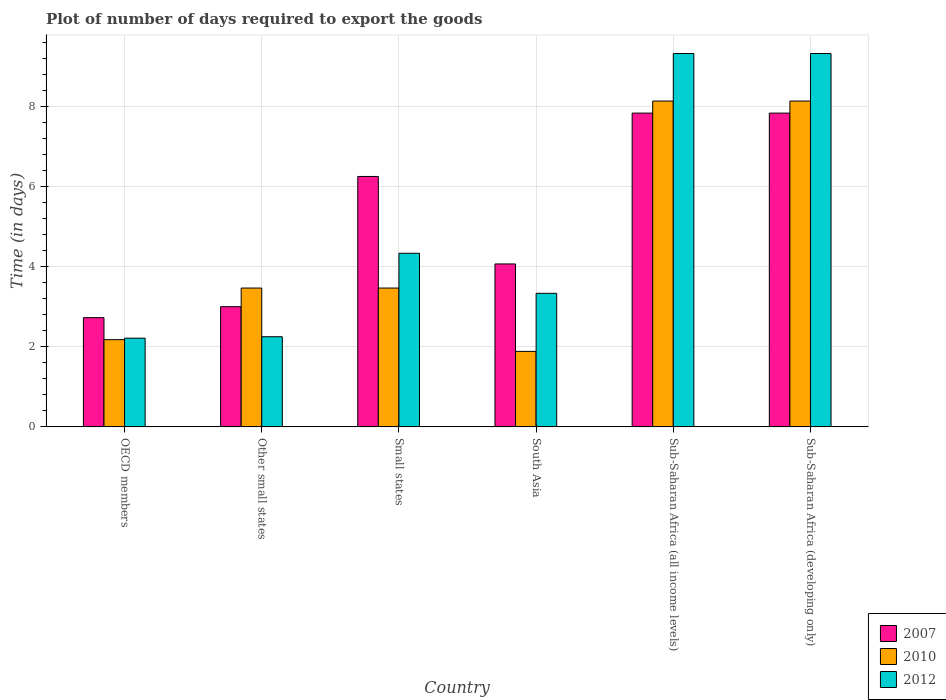How many different coloured bars are there?
Keep it short and to the point. 3. Are the number of bars on each tick of the X-axis equal?
Make the answer very short. Yes. How many bars are there on the 6th tick from the left?
Your response must be concise. 3. How many bars are there on the 2nd tick from the right?
Provide a short and direct response. 3. What is the label of the 2nd group of bars from the left?
Keep it short and to the point. Other small states. Across all countries, what is the maximum time required to export goods in 2010?
Offer a terse response. 8.13. Across all countries, what is the minimum time required to export goods in 2012?
Offer a very short reply. 2.21. In which country was the time required to export goods in 2012 maximum?
Offer a very short reply. Sub-Saharan Africa (all income levels). In which country was the time required to export goods in 2010 minimum?
Your response must be concise. South Asia. What is the total time required to export goods in 2007 in the graph?
Make the answer very short. 31.71. What is the difference between the time required to export goods in 2012 in OECD members and that in Small states?
Give a very brief answer. -2.12. What is the difference between the time required to export goods in 2010 in Small states and the time required to export goods in 2012 in OECD members?
Give a very brief answer. 1.25. What is the average time required to export goods in 2012 per country?
Give a very brief answer. 5.13. What is the difference between the time required to export goods of/in 2007 and time required to export goods of/in 2010 in Small states?
Offer a very short reply. 2.79. In how many countries, is the time required to export goods in 2010 greater than 8 days?
Give a very brief answer. 2. What is the ratio of the time required to export goods in 2010 in Small states to that in South Asia?
Ensure brevity in your answer.  1.84. Is the time required to export goods in 2010 in South Asia less than that in Sub-Saharan Africa (developing only)?
Make the answer very short. Yes. What is the difference between the highest and the second highest time required to export goods in 2010?
Offer a very short reply. 4.67. What is the difference between the highest and the lowest time required to export goods in 2010?
Keep it short and to the point. 6.25. What does the 1st bar from the left in OECD members represents?
Provide a succinct answer. 2007. Is it the case that in every country, the sum of the time required to export goods in 2010 and time required to export goods in 2007 is greater than the time required to export goods in 2012?
Make the answer very short. Yes. How many bars are there?
Keep it short and to the point. 18. Does the graph contain any zero values?
Ensure brevity in your answer.  No. Where does the legend appear in the graph?
Make the answer very short. Bottom right. How are the legend labels stacked?
Offer a very short reply. Vertical. What is the title of the graph?
Offer a very short reply. Plot of number of days required to export the goods. What is the label or title of the Y-axis?
Provide a short and direct response. Time (in days). What is the Time (in days) in 2007 in OECD members?
Provide a short and direct response. 2.73. What is the Time (in days) of 2010 in OECD members?
Provide a succinct answer. 2.18. What is the Time (in days) of 2012 in OECD members?
Your answer should be compact. 2.21. What is the Time (in days) of 2007 in Other small states?
Give a very brief answer. 3. What is the Time (in days) of 2010 in Other small states?
Keep it short and to the point. 3.46. What is the Time (in days) of 2012 in Other small states?
Your answer should be compact. 2.25. What is the Time (in days) of 2007 in Small states?
Keep it short and to the point. 6.25. What is the Time (in days) of 2010 in Small states?
Keep it short and to the point. 3.46. What is the Time (in days) of 2012 in Small states?
Provide a succinct answer. 4.33. What is the Time (in days) of 2007 in South Asia?
Make the answer very short. 4.07. What is the Time (in days) in 2010 in South Asia?
Your answer should be compact. 1.88. What is the Time (in days) of 2012 in South Asia?
Make the answer very short. 3.33. What is the Time (in days) of 2007 in Sub-Saharan Africa (all income levels)?
Offer a very short reply. 7.83. What is the Time (in days) in 2010 in Sub-Saharan Africa (all income levels)?
Your answer should be very brief. 8.13. What is the Time (in days) of 2012 in Sub-Saharan Africa (all income levels)?
Ensure brevity in your answer.  9.32. What is the Time (in days) of 2007 in Sub-Saharan Africa (developing only)?
Make the answer very short. 7.83. What is the Time (in days) of 2010 in Sub-Saharan Africa (developing only)?
Provide a succinct answer. 8.13. What is the Time (in days) of 2012 in Sub-Saharan Africa (developing only)?
Ensure brevity in your answer.  9.32. Across all countries, what is the maximum Time (in days) in 2007?
Keep it short and to the point. 7.83. Across all countries, what is the maximum Time (in days) of 2010?
Your answer should be compact. 8.13. Across all countries, what is the maximum Time (in days) in 2012?
Keep it short and to the point. 9.32. Across all countries, what is the minimum Time (in days) in 2007?
Give a very brief answer. 2.73. Across all countries, what is the minimum Time (in days) in 2010?
Give a very brief answer. 1.88. Across all countries, what is the minimum Time (in days) of 2012?
Provide a succinct answer. 2.21. What is the total Time (in days) of 2007 in the graph?
Keep it short and to the point. 31.71. What is the total Time (in days) in 2010 in the graph?
Offer a very short reply. 27.26. What is the total Time (in days) in 2012 in the graph?
Provide a short and direct response. 30.77. What is the difference between the Time (in days) in 2007 in OECD members and that in Other small states?
Make the answer very short. -0.27. What is the difference between the Time (in days) of 2010 in OECD members and that in Other small states?
Keep it short and to the point. -1.29. What is the difference between the Time (in days) in 2012 in OECD members and that in Other small states?
Your answer should be compact. -0.04. What is the difference between the Time (in days) in 2007 in OECD members and that in Small states?
Your answer should be compact. -3.52. What is the difference between the Time (in days) in 2010 in OECD members and that in Small states?
Provide a succinct answer. -1.29. What is the difference between the Time (in days) in 2012 in OECD members and that in Small states?
Make the answer very short. -2.12. What is the difference between the Time (in days) of 2007 in OECD members and that in South Asia?
Your response must be concise. -1.34. What is the difference between the Time (in days) in 2010 in OECD members and that in South Asia?
Make the answer very short. 0.29. What is the difference between the Time (in days) of 2012 in OECD members and that in South Asia?
Give a very brief answer. -1.12. What is the difference between the Time (in days) in 2007 in OECD members and that in Sub-Saharan Africa (all income levels)?
Offer a very short reply. -5.11. What is the difference between the Time (in days) in 2010 in OECD members and that in Sub-Saharan Africa (all income levels)?
Your answer should be compact. -5.96. What is the difference between the Time (in days) of 2012 in OECD members and that in Sub-Saharan Africa (all income levels)?
Offer a terse response. -7.1. What is the difference between the Time (in days) of 2007 in OECD members and that in Sub-Saharan Africa (developing only)?
Your answer should be very brief. -5.11. What is the difference between the Time (in days) of 2010 in OECD members and that in Sub-Saharan Africa (developing only)?
Your response must be concise. -5.96. What is the difference between the Time (in days) of 2012 in OECD members and that in Sub-Saharan Africa (developing only)?
Provide a short and direct response. -7.1. What is the difference between the Time (in days) of 2007 in Other small states and that in Small states?
Provide a short and direct response. -3.25. What is the difference between the Time (in days) of 2010 in Other small states and that in Small states?
Provide a short and direct response. 0. What is the difference between the Time (in days) of 2012 in Other small states and that in Small states?
Give a very brief answer. -2.08. What is the difference between the Time (in days) of 2007 in Other small states and that in South Asia?
Offer a very short reply. -1.07. What is the difference between the Time (in days) in 2010 in Other small states and that in South Asia?
Make the answer very short. 1.58. What is the difference between the Time (in days) in 2012 in Other small states and that in South Asia?
Give a very brief answer. -1.08. What is the difference between the Time (in days) in 2007 in Other small states and that in Sub-Saharan Africa (all income levels)?
Give a very brief answer. -4.83. What is the difference between the Time (in days) in 2010 in Other small states and that in Sub-Saharan Africa (all income levels)?
Offer a very short reply. -4.67. What is the difference between the Time (in days) of 2012 in Other small states and that in Sub-Saharan Africa (all income levels)?
Your response must be concise. -7.07. What is the difference between the Time (in days) in 2007 in Other small states and that in Sub-Saharan Africa (developing only)?
Your answer should be compact. -4.83. What is the difference between the Time (in days) of 2010 in Other small states and that in Sub-Saharan Africa (developing only)?
Your answer should be compact. -4.67. What is the difference between the Time (in days) in 2012 in Other small states and that in Sub-Saharan Africa (developing only)?
Your answer should be very brief. -7.07. What is the difference between the Time (in days) of 2007 in Small states and that in South Asia?
Provide a short and direct response. 2.18. What is the difference between the Time (in days) of 2010 in Small states and that in South Asia?
Keep it short and to the point. 1.58. What is the difference between the Time (in days) in 2007 in Small states and that in Sub-Saharan Africa (all income levels)?
Your response must be concise. -1.58. What is the difference between the Time (in days) of 2010 in Small states and that in Sub-Saharan Africa (all income levels)?
Ensure brevity in your answer.  -4.67. What is the difference between the Time (in days) of 2012 in Small states and that in Sub-Saharan Africa (all income levels)?
Provide a short and direct response. -4.98. What is the difference between the Time (in days) of 2007 in Small states and that in Sub-Saharan Africa (developing only)?
Provide a succinct answer. -1.58. What is the difference between the Time (in days) in 2010 in Small states and that in Sub-Saharan Africa (developing only)?
Give a very brief answer. -4.67. What is the difference between the Time (in days) in 2012 in Small states and that in Sub-Saharan Africa (developing only)?
Offer a terse response. -4.98. What is the difference between the Time (in days) in 2007 in South Asia and that in Sub-Saharan Africa (all income levels)?
Your answer should be compact. -3.76. What is the difference between the Time (in days) in 2010 in South Asia and that in Sub-Saharan Africa (all income levels)?
Offer a very short reply. -6.25. What is the difference between the Time (in days) in 2012 in South Asia and that in Sub-Saharan Africa (all income levels)?
Provide a succinct answer. -5.98. What is the difference between the Time (in days) in 2007 in South Asia and that in Sub-Saharan Africa (developing only)?
Make the answer very short. -3.76. What is the difference between the Time (in days) in 2010 in South Asia and that in Sub-Saharan Africa (developing only)?
Your answer should be compact. -6.25. What is the difference between the Time (in days) of 2012 in South Asia and that in Sub-Saharan Africa (developing only)?
Keep it short and to the point. -5.98. What is the difference between the Time (in days) in 2007 in Sub-Saharan Africa (all income levels) and that in Sub-Saharan Africa (developing only)?
Your answer should be compact. 0. What is the difference between the Time (in days) in 2007 in OECD members and the Time (in days) in 2010 in Other small states?
Your answer should be very brief. -0.74. What is the difference between the Time (in days) of 2007 in OECD members and the Time (in days) of 2012 in Other small states?
Your response must be concise. 0.48. What is the difference between the Time (in days) in 2010 in OECD members and the Time (in days) in 2012 in Other small states?
Give a very brief answer. -0.07. What is the difference between the Time (in days) of 2007 in OECD members and the Time (in days) of 2010 in Small states?
Offer a terse response. -0.74. What is the difference between the Time (in days) of 2007 in OECD members and the Time (in days) of 2012 in Small states?
Ensure brevity in your answer.  -1.61. What is the difference between the Time (in days) of 2010 in OECD members and the Time (in days) of 2012 in Small states?
Offer a terse response. -2.16. What is the difference between the Time (in days) of 2007 in OECD members and the Time (in days) of 2010 in South Asia?
Make the answer very short. 0.84. What is the difference between the Time (in days) of 2007 in OECD members and the Time (in days) of 2012 in South Asia?
Ensure brevity in your answer.  -0.61. What is the difference between the Time (in days) of 2010 in OECD members and the Time (in days) of 2012 in South Asia?
Your answer should be compact. -1.16. What is the difference between the Time (in days) in 2007 in OECD members and the Time (in days) in 2010 in Sub-Saharan Africa (all income levels)?
Your answer should be very brief. -5.41. What is the difference between the Time (in days) in 2007 in OECD members and the Time (in days) in 2012 in Sub-Saharan Africa (all income levels)?
Ensure brevity in your answer.  -6.59. What is the difference between the Time (in days) in 2010 in OECD members and the Time (in days) in 2012 in Sub-Saharan Africa (all income levels)?
Ensure brevity in your answer.  -7.14. What is the difference between the Time (in days) in 2007 in OECD members and the Time (in days) in 2010 in Sub-Saharan Africa (developing only)?
Offer a terse response. -5.41. What is the difference between the Time (in days) in 2007 in OECD members and the Time (in days) in 2012 in Sub-Saharan Africa (developing only)?
Provide a succinct answer. -6.59. What is the difference between the Time (in days) of 2010 in OECD members and the Time (in days) of 2012 in Sub-Saharan Africa (developing only)?
Offer a very short reply. -7.14. What is the difference between the Time (in days) in 2007 in Other small states and the Time (in days) in 2010 in Small states?
Make the answer very short. -0.47. What is the difference between the Time (in days) in 2007 in Other small states and the Time (in days) in 2012 in Small states?
Offer a very short reply. -1.33. What is the difference between the Time (in days) in 2010 in Other small states and the Time (in days) in 2012 in Small states?
Your response must be concise. -0.87. What is the difference between the Time (in days) in 2007 in Other small states and the Time (in days) in 2010 in South Asia?
Provide a succinct answer. 1.12. What is the difference between the Time (in days) of 2010 in Other small states and the Time (in days) of 2012 in South Asia?
Your response must be concise. 0.13. What is the difference between the Time (in days) of 2007 in Other small states and the Time (in days) of 2010 in Sub-Saharan Africa (all income levels)?
Offer a terse response. -5.13. What is the difference between the Time (in days) of 2007 in Other small states and the Time (in days) of 2012 in Sub-Saharan Africa (all income levels)?
Make the answer very short. -6.32. What is the difference between the Time (in days) of 2010 in Other small states and the Time (in days) of 2012 in Sub-Saharan Africa (all income levels)?
Your answer should be compact. -5.85. What is the difference between the Time (in days) of 2007 in Other small states and the Time (in days) of 2010 in Sub-Saharan Africa (developing only)?
Provide a succinct answer. -5.13. What is the difference between the Time (in days) in 2007 in Other small states and the Time (in days) in 2012 in Sub-Saharan Africa (developing only)?
Give a very brief answer. -6.32. What is the difference between the Time (in days) of 2010 in Other small states and the Time (in days) of 2012 in Sub-Saharan Africa (developing only)?
Your answer should be very brief. -5.85. What is the difference between the Time (in days) of 2007 in Small states and the Time (in days) of 2010 in South Asia?
Your response must be concise. 4.37. What is the difference between the Time (in days) in 2007 in Small states and the Time (in days) in 2012 in South Asia?
Ensure brevity in your answer.  2.92. What is the difference between the Time (in days) of 2010 in Small states and the Time (in days) of 2012 in South Asia?
Provide a succinct answer. 0.13. What is the difference between the Time (in days) in 2007 in Small states and the Time (in days) in 2010 in Sub-Saharan Africa (all income levels)?
Your answer should be compact. -1.88. What is the difference between the Time (in days) in 2007 in Small states and the Time (in days) in 2012 in Sub-Saharan Africa (all income levels)?
Your answer should be compact. -3.07. What is the difference between the Time (in days) of 2010 in Small states and the Time (in days) of 2012 in Sub-Saharan Africa (all income levels)?
Make the answer very short. -5.85. What is the difference between the Time (in days) in 2007 in Small states and the Time (in days) in 2010 in Sub-Saharan Africa (developing only)?
Ensure brevity in your answer.  -1.88. What is the difference between the Time (in days) in 2007 in Small states and the Time (in days) in 2012 in Sub-Saharan Africa (developing only)?
Provide a short and direct response. -3.07. What is the difference between the Time (in days) in 2010 in Small states and the Time (in days) in 2012 in Sub-Saharan Africa (developing only)?
Make the answer very short. -5.85. What is the difference between the Time (in days) of 2007 in South Asia and the Time (in days) of 2010 in Sub-Saharan Africa (all income levels)?
Provide a succinct answer. -4.07. What is the difference between the Time (in days) of 2007 in South Asia and the Time (in days) of 2012 in Sub-Saharan Africa (all income levels)?
Your response must be concise. -5.25. What is the difference between the Time (in days) of 2010 in South Asia and the Time (in days) of 2012 in Sub-Saharan Africa (all income levels)?
Ensure brevity in your answer.  -7.43. What is the difference between the Time (in days) in 2007 in South Asia and the Time (in days) in 2010 in Sub-Saharan Africa (developing only)?
Keep it short and to the point. -4.07. What is the difference between the Time (in days) in 2007 in South Asia and the Time (in days) in 2012 in Sub-Saharan Africa (developing only)?
Offer a terse response. -5.25. What is the difference between the Time (in days) in 2010 in South Asia and the Time (in days) in 2012 in Sub-Saharan Africa (developing only)?
Give a very brief answer. -7.43. What is the difference between the Time (in days) of 2007 in Sub-Saharan Africa (all income levels) and the Time (in days) of 2010 in Sub-Saharan Africa (developing only)?
Your answer should be very brief. -0.3. What is the difference between the Time (in days) of 2007 in Sub-Saharan Africa (all income levels) and the Time (in days) of 2012 in Sub-Saharan Africa (developing only)?
Provide a short and direct response. -1.49. What is the difference between the Time (in days) in 2010 in Sub-Saharan Africa (all income levels) and the Time (in days) in 2012 in Sub-Saharan Africa (developing only)?
Offer a terse response. -1.19. What is the average Time (in days) in 2007 per country?
Give a very brief answer. 5.28. What is the average Time (in days) in 2010 per country?
Give a very brief answer. 4.54. What is the average Time (in days) in 2012 per country?
Your response must be concise. 5.13. What is the difference between the Time (in days) of 2007 and Time (in days) of 2010 in OECD members?
Give a very brief answer. 0.55. What is the difference between the Time (in days) in 2007 and Time (in days) in 2012 in OECD members?
Make the answer very short. 0.51. What is the difference between the Time (in days) in 2010 and Time (in days) in 2012 in OECD members?
Your response must be concise. -0.04. What is the difference between the Time (in days) in 2007 and Time (in days) in 2010 in Other small states?
Your answer should be very brief. -0.47. What is the difference between the Time (in days) of 2010 and Time (in days) of 2012 in Other small states?
Your response must be concise. 1.22. What is the difference between the Time (in days) of 2007 and Time (in days) of 2010 in Small states?
Make the answer very short. 2.79. What is the difference between the Time (in days) of 2007 and Time (in days) of 2012 in Small states?
Your response must be concise. 1.92. What is the difference between the Time (in days) of 2010 and Time (in days) of 2012 in Small states?
Keep it short and to the point. -0.87. What is the difference between the Time (in days) in 2007 and Time (in days) in 2010 in South Asia?
Make the answer very short. 2.18. What is the difference between the Time (in days) in 2007 and Time (in days) in 2012 in South Asia?
Ensure brevity in your answer.  0.73. What is the difference between the Time (in days) of 2010 and Time (in days) of 2012 in South Asia?
Provide a short and direct response. -1.45. What is the difference between the Time (in days) of 2007 and Time (in days) of 2010 in Sub-Saharan Africa (all income levels)?
Your answer should be compact. -0.3. What is the difference between the Time (in days) of 2007 and Time (in days) of 2012 in Sub-Saharan Africa (all income levels)?
Offer a terse response. -1.49. What is the difference between the Time (in days) in 2010 and Time (in days) in 2012 in Sub-Saharan Africa (all income levels)?
Make the answer very short. -1.19. What is the difference between the Time (in days) in 2007 and Time (in days) in 2010 in Sub-Saharan Africa (developing only)?
Your response must be concise. -0.3. What is the difference between the Time (in days) in 2007 and Time (in days) in 2012 in Sub-Saharan Africa (developing only)?
Make the answer very short. -1.49. What is the difference between the Time (in days) of 2010 and Time (in days) of 2012 in Sub-Saharan Africa (developing only)?
Offer a very short reply. -1.19. What is the ratio of the Time (in days) of 2007 in OECD members to that in Other small states?
Your answer should be compact. 0.91. What is the ratio of the Time (in days) in 2010 in OECD members to that in Other small states?
Your answer should be compact. 0.63. What is the ratio of the Time (in days) of 2012 in OECD members to that in Other small states?
Make the answer very short. 0.98. What is the ratio of the Time (in days) in 2007 in OECD members to that in Small states?
Your answer should be very brief. 0.44. What is the ratio of the Time (in days) in 2010 in OECD members to that in Small states?
Offer a terse response. 0.63. What is the ratio of the Time (in days) in 2012 in OECD members to that in Small states?
Provide a succinct answer. 0.51. What is the ratio of the Time (in days) in 2007 in OECD members to that in South Asia?
Offer a terse response. 0.67. What is the ratio of the Time (in days) of 2010 in OECD members to that in South Asia?
Offer a very short reply. 1.16. What is the ratio of the Time (in days) in 2012 in OECD members to that in South Asia?
Your answer should be compact. 0.66. What is the ratio of the Time (in days) in 2007 in OECD members to that in Sub-Saharan Africa (all income levels)?
Provide a succinct answer. 0.35. What is the ratio of the Time (in days) of 2010 in OECD members to that in Sub-Saharan Africa (all income levels)?
Your answer should be very brief. 0.27. What is the ratio of the Time (in days) of 2012 in OECD members to that in Sub-Saharan Africa (all income levels)?
Your answer should be very brief. 0.24. What is the ratio of the Time (in days) in 2007 in OECD members to that in Sub-Saharan Africa (developing only)?
Give a very brief answer. 0.35. What is the ratio of the Time (in days) of 2010 in OECD members to that in Sub-Saharan Africa (developing only)?
Provide a succinct answer. 0.27. What is the ratio of the Time (in days) in 2012 in OECD members to that in Sub-Saharan Africa (developing only)?
Your answer should be very brief. 0.24. What is the ratio of the Time (in days) of 2007 in Other small states to that in Small states?
Provide a short and direct response. 0.48. What is the ratio of the Time (in days) of 2012 in Other small states to that in Small states?
Provide a succinct answer. 0.52. What is the ratio of the Time (in days) in 2007 in Other small states to that in South Asia?
Give a very brief answer. 0.74. What is the ratio of the Time (in days) of 2010 in Other small states to that in South Asia?
Make the answer very short. 1.84. What is the ratio of the Time (in days) of 2012 in Other small states to that in South Asia?
Give a very brief answer. 0.68. What is the ratio of the Time (in days) of 2007 in Other small states to that in Sub-Saharan Africa (all income levels)?
Provide a succinct answer. 0.38. What is the ratio of the Time (in days) of 2010 in Other small states to that in Sub-Saharan Africa (all income levels)?
Offer a terse response. 0.43. What is the ratio of the Time (in days) of 2012 in Other small states to that in Sub-Saharan Africa (all income levels)?
Your response must be concise. 0.24. What is the ratio of the Time (in days) in 2007 in Other small states to that in Sub-Saharan Africa (developing only)?
Provide a succinct answer. 0.38. What is the ratio of the Time (in days) of 2010 in Other small states to that in Sub-Saharan Africa (developing only)?
Your response must be concise. 0.43. What is the ratio of the Time (in days) of 2012 in Other small states to that in Sub-Saharan Africa (developing only)?
Provide a short and direct response. 0.24. What is the ratio of the Time (in days) of 2007 in Small states to that in South Asia?
Your answer should be compact. 1.54. What is the ratio of the Time (in days) of 2010 in Small states to that in South Asia?
Give a very brief answer. 1.84. What is the ratio of the Time (in days) in 2007 in Small states to that in Sub-Saharan Africa (all income levels)?
Keep it short and to the point. 0.8. What is the ratio of the Time (in days) in 2010 in Small states to that in Sub-Saharan Africa (all income levels)?
Keep it short and to the point. 0.43. What is the ratio of the Time (in days) of 2012 in Small states to that in Sub-Saharan Africa (all income levels)?
Offer a terse response. 0.47. What is the ratio of the Time (in days) of 2007 in Small states to that in Sub-Saharan Africa (developing only)?
Your answer should be very brief. 0.8. What is the ratio of the Time (in days) of 2010 in Small states to that in Sub-Saharan Africa (developing only)?
Your answer should be very brief. 0.43. What is the ratio of the Time (in days) in 2012 in Small states to that in Sub-Saharan Africa (developing only)?
Keep it short and to the point. 0.47. What is the ratio of the Time (in days) in 2007 in South Asia to that in Sub-Saharan Africa (all income levels)?
Provide a short and direct response. 0.52. What is the ratio of the Time (in days) of 2010 in South Asia to that in Sub-Saharan Africa (all income levels)?
Provide a short and direct response. 0.23. What is the ratio of the Time (in days) of 2012 in South Asia to that in Sub-Saharan Africa (all income levels)?
Ensure brevity in your answer.  0.36. What is the ratio of the Time (in days) in 2007 in South Asia to that in Sub-Saharan Africa (developing only)?
Keep it short and to the point. 0.52. What is the ratio of the Time (in days) of 2010 in South Asia to that in Sub-Saharan Africa (developing only)?
Give a very brief answer. 0.23. What is the ratio of the Time (in days) in 2012 in South Asia to that in Sub-Saharan Africa (developing only)?
Provide a short and direct response. 0.36. What is the ratio of the Time (in days) of 2007 in Sub-Saharan Africa (all income levels) to that in Sub-Saharan Africa (developing only)?
Keep it short and to the point. 1. What is the ratio of the Time (in days) of 2012 in Sub-Saharan Africa (all income levels) to that in Sub-Saharan Africa (developing only)?
Your answer should be very brief. 1. What is the difference between the highest and the second highest Time (in days) of 2007?
Give a very brief answer. 0. What is the difference between the highest and the second highest Time (in days) of 2012?
Your answer should be very brief. 0. What is the difference between the highest and the lowest Time (in days) of 2007?
Keep it short and to the point. 5.11. What is the difference between the highest and the lowest Time (in days) of 2010?
Ensure brevity in your answer.  6.25. What is the difference between the highest and the lowest Time (in days) of 2012?
Make the answer very short. 7.1. 